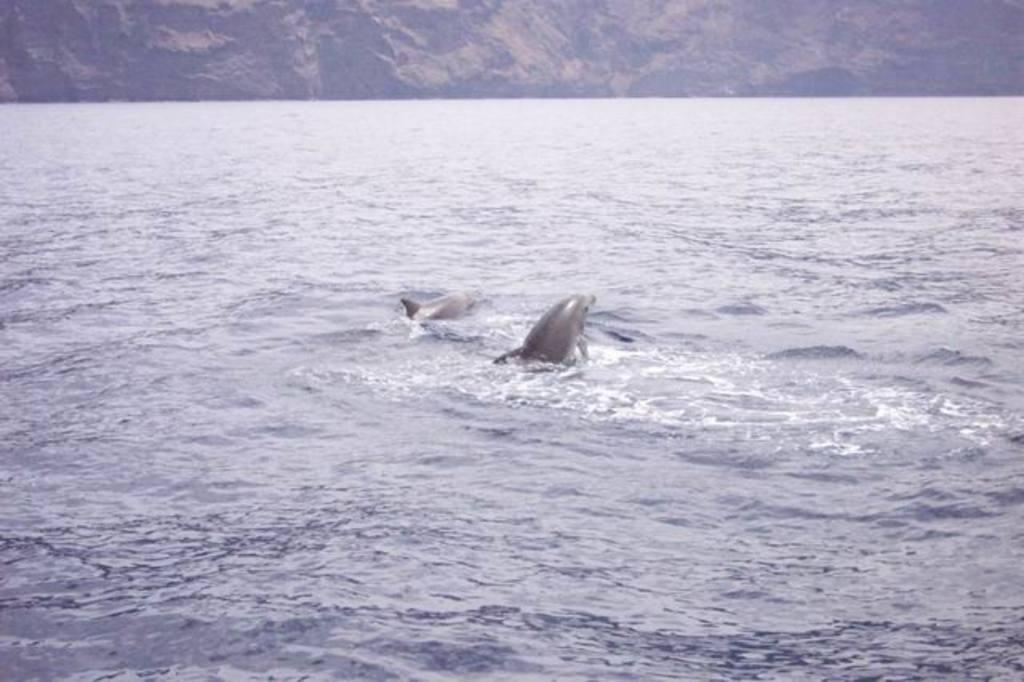What animals can be seen in the water in the image? There are dolphins in the water in the foreground area of the image. What type of landscape can be seen in the background of the image? It appears that there are mountains in the background of the image. What type of lunch is being served on a square plate in the image? There is no lunch or plate present in the image; it features dolphins in the water and mountains in the background. 